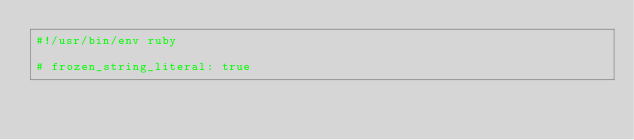<code> <loc_0><loc_0><loc_500><loc_500><_Ruby_>#!/usr/bin/env ruby

# frozen_string_literal: true
</code> 